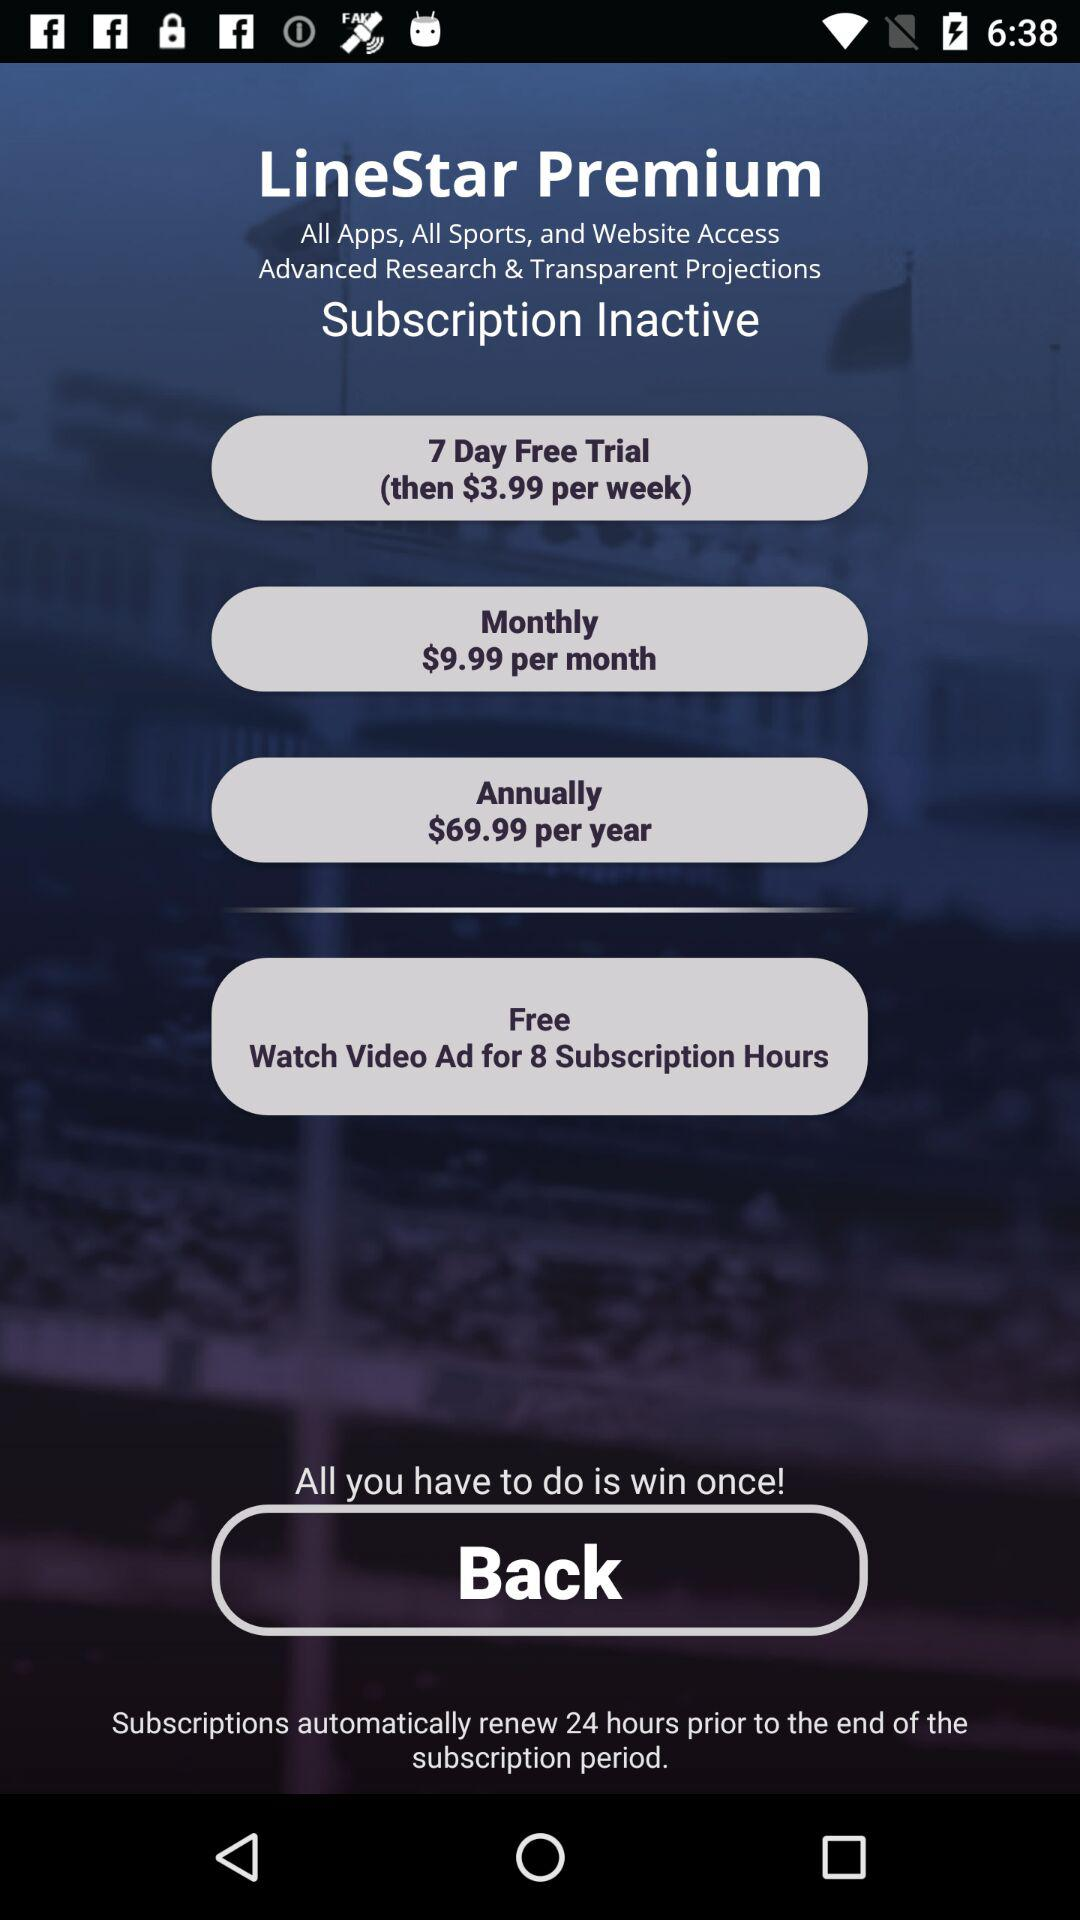What are the monthly charges? The monthly charges are $9.99. 